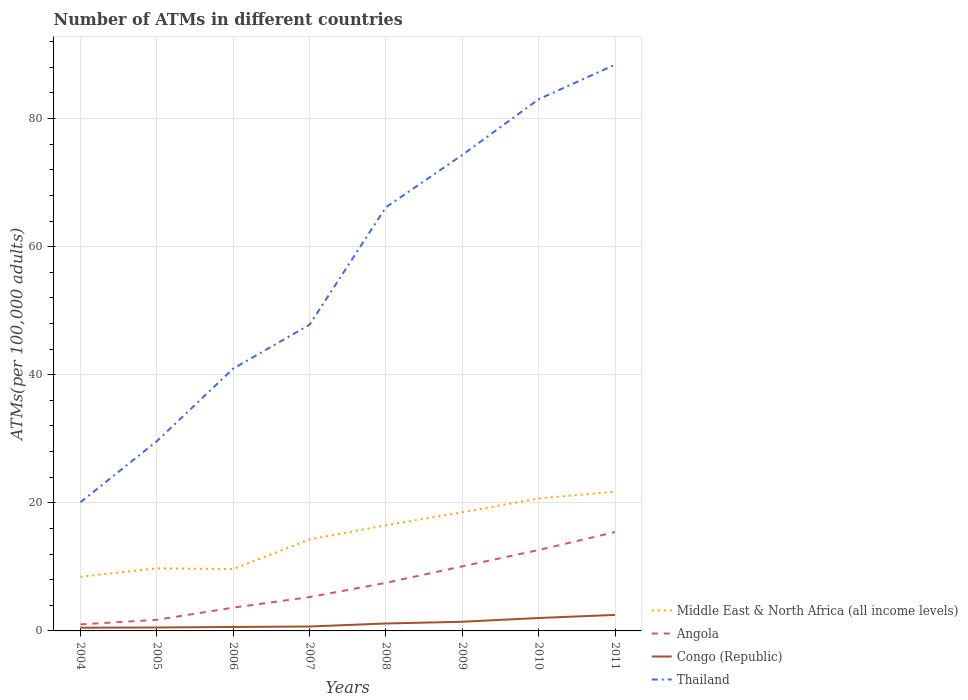Across all years, what is the maximum number of ATMs in Congo (Republic)?
Offer a very short reply. 0.5. In which year was the number of ATMs in Congo (Republic) maximum?
Give a very brief answer. 2004. What is the total number of ATMs in Middle East & North Africa (all income levels) in the graph?
Ensure brevity in your answer.  -5.83. What is the difference between the highest and the second highest number of ATMs in Congo (Republic)?
Ensure brevity in your answer.  2. Is the number of ATMs in Middle East & North Africa (all income levels) strictly greater than the number of ATMs in Angola over the years?
Your answer should be compact. No. How many years are there in the graph?
Your answer should be compact. 8. What is the difference between two consecutive major ticks on the Y-axis?
Make the answer very short. 20. How many legend labels are there?
Offer a very short reply. 4. How are the legend labels stacked?
Offer a very short reply. Vertical. What is the title of the graph?
Your answer should be very brief. Number of ATMs in different countries. Does "Djibouti" appear as one of the legend labels in the graph?
Keep it short and to the point. No. What is the label or title of the Y-axis?
Your answer should be very brief. ATMs(per 100,0 adults). What is the ATMs(per 100,000 adults) in Middle East & North Africa (all income levels) in 2004?
Your response must be concise. 8.46. What is the ATMs(per 100,000 adults) in Angola in 2004?
Make the answer very short. 1.02. What is the ATMs(per 100,000 adults) in Congo (Republic) in 2004?
Give a very brief answer. 0.5. What is the ATMs(per 100,000 adults) in Thailand in 2004?
Make the answer very short. 20.09. What is the ATMs(per 100,000 adults) in Middle East & North Africa (all income levels) in 2005?
Provide a short and direct response. 9.77. What is the ATMs(per 100,000 adults) of Angola in 2005?
Offer a very short reply. 1.74. What is the ATMs(per 100,000 adults) of Congo (Republic) in 2005?
Make the answer very short. 0.54. What is the ATMs(per 100,000 adults) in Thailand in 2005?
Your answer should be compact. 29.62. What is the ATMs(per 100,000 adults) in Middle East & North Africa (all income levels) in 2006?
Offer a very short reply. 9.67. What is the ATMs(per 100,000 adults) of Angola in 2006?
Provide a succinct answer. 3.64. What is the ATMs(per 100,000 adults) of Congo (Republic) in 2006?
Give a very brief answer. 0.62. What is the ATMs(per 100,000 adults) in Thailand in 2006?
Keep it short and to the point. 40.95. What is the ATMs(per 100,000 adults) in Middle East & North Africa (all income levels) in 2007?
Your answer should be compact. 14.28. What is the ATMs(per 100,000 adults) of Angola in 2007?
Provide a succinct answer. 5.28. What is the ATMs(per 100,000 adults) of Congo (Republic) in 2007?
Keep it short and to the point. 0.69. What is the ATMs(per 100,000 adults) in Thailand in 2007?
Give a very brief answer. 47.81. What is the ATMs(per 100,000 adults) of Middle East & North Africa (all income levels) in 2008?
Ensure brevity in your answer.  16.5. What is the ATMs(per 100,000 adults) of Angola in 2008?
Your answer should be compact. 7.51. What is the ATMs(per 100,000 adults) in Congo (Republic) in 2008?
Your response must be concise. 1.16. What is the ATMs(per 100,000 adults) of Thailand in 2008?
Keep it short and to the point. 66.15. What is the ATMs(per 100,000 adults) in Middle East & North Africa (all income levels) in 2009?
Offer a very short reply. 18.52. What is the ATMs(per 100,000 adults) in Angola in 2009?
Provide a succinct answer. 10.08. What is the ATMs(per 100,000 adults) in Congo (Republic) in 2009?
Make the answer very short. 1.43. What is the ATMs(per 100,000 adults) in Thailand in 2009?
Offer a terse response. 74.32. What is the ATMs(per 100,000 adults) of Middle East & North Africa (all income levels) in 2010?
Give a very brief answer. 20.68. What is the ATMs(per 100,000 adults) in Angola in 2010?
Offer a terse response. 12.63. What is the ATMs(per 100,000 adults) in Congo (Republic) in 2010?
Your answer should be compact. 2.02. What is the ATMs(per 100,000 adults) in Thailand in 2010?
Provide a short and direct response. 83.02. What is the ATMs(per 100,000 adults) of Middle East & North Africa (all income levels) in 2011?
Provide a succinct answer. 21.74. What is the ATMs(per 100,000 adults) of Angola in 2011?
Give a very brief answer. 15.44. What is the ATMs(per 100,000 adults) of Congo (Republic) in 2011?
Provide a short and direct response. 2.5. What is the ATMs(per 100,000 adults) in Thailand in 2011?
Your answer should be compact. 88.41. Across all years, what is the maximum ATMs(per 100,000 adults) in Middle East & North Africa (all income levels)?
Give a very brief answer. 21.74. Across all years, what is the maximum ATMs(per 100,000 adults) of Angola?
Ensure brevity in your answer.  15.44. Across all years, what is the maximum ATMs(per 100,000 adults) in Congo (Republic)?
Offer a terse response. 2.5. Across all years, what is the maximum ATMs(per 100,000 adults) of Thailand?
Ensure brevity in your answer.  88.41. Across all years, what is the minimum ATMs(per 100,000 adults) in Middle East & North Africa (all income levels)?
Provide a succinct answer. 8.46. Across all years, what is the minimum ATMs(per 100,000 adults) in Angola?
Your answer should be compact. 1.02. Across all years, what is the minimum ATMs(per 100,000 adults) of Congo (Republic)?
Provide a short and direct response. 0.5. Across all years, what is the minimum ATMs(per 100,000 adults) of Thailand?
Ensure brevity in your answer.  20.09. What is the total ATMs(per 100,000 adults) of Middle East & North Africa (all income levels) in the graph?
Give a very brief answer. 119.62. What is the total ATMs(per 100,000 adults) in Angola in the graph?
Ensure brevity in your answer.  57.34. What is the total ATMs(per 100,000 adults) of Congo (Republic) in the graph?
Provide a succinct answer. 9.46. What is the total ATMs(per 100,000 adults) in Thailand in the graph?
Offer a terse response. 450.38. What is the difference between the ATMs(per 100,000 adults) in Middle East & North Africa (all income levels) in 2004 and that in 2005?
Keep it short and to the point. -1.31. What is the difference between the ATMs(per 100,000 adults) in Angola in 2004 and that in 2005?
Your answer should be very brief. -0.72. What is the difference between the ATMs(per 100,000 adults) in Congo (Republic) in 2004 and that in 2005?
Offer a terse response. -0.04. What is the difference between the ATMs(per 100,000 adults) of Thailand in 2004 and that in 2005?
Ensure brevity in your answer.  -9.53. What is the difference between the ATMs(per 100,000 adults) in Middle East & North Africa (all income levels) in 2004 and that in 2006?
Offer a terse response. -1.21. What is the difference between the ATMs(per 100,000 adults) in Angola in 2004 and that in 2006?
Ensure brevity in your answer.  -2.62. What is the difference between the ATMs(per 100,000 adults) of Congo (Republic) in 2004 and that in 2006?
Give a very brief answer. -0.12. What is the difference between the ATMs(per 100,000 adults) in Thailand in 2004 and that in 2006?
Your answer should be compact. -20.86. What is the difference between the ATMs(per 100,000 adults) in Middle East & North Africa (all income levels) in 2004 and that in 2007?
Your answer should be compact. -5.83. What is the difference between the ATMs(per 100,000 adults) of Angola in 2004 and that in 2007?
Offer a terse response. -4.26. What is the difference between the ATMs(per 100,000 adults) of Congo (Republic) in 2004 and that in 2007?
Make the answer very short. -0.19. What is the difference between the ATMs(per 100,000 adults) in Thailand in 2004 and that in 2007?
Offer a terse response. -27.72. What is the difference between the ATMs(per 100,000 adults) in Middle East & North Africa (all income levels) in 2004 and that in 2008?
Provide a short and direct response. -8.04. What is the difference between the ATMs(per 100,000 adults) of Angola in 2004 and that in 2008?
Ensure brevity in your answer.  -6.49. What is the difference between the ATMs(per 100,000 adults) of Congo (Republic) in 2004 and that in 2008?
Your response must be concise. -0.66. What is the difference between the ATMs(per 100,000 adults) in Thailand in 2004 and that in 2008?
Offer a very short reply. -46.06. What is the difference between the ATMs(per 100,000 adults) in Middle East & North Africa (all income levels) in 2004 and that in 2009?
Your answer should be very brief. -10.07. What is the difference between the ATMs(per 100,000 adults) in Angola in 2004 and that in 2009?
Your answer should be compact. -9.06. What is the difference between the ATMs(per 100,000 adults) in Congo (Republic) in 2004 and that in 2009?
Keep it short and to the point. -0.93. What is the difference between the ATMs(per 100,000 adults) in Thailand in 2004 and that in 2009?
Your answer should be compact. -54.23. What is the difference between the ATMs(per 100,000 adults) of Middle East & North Africa (all income levels) in 2004 and that in 2010?
Give a very brief answer. -12.23. What is the difference between the ATMs(per 100,000 adults) in Angola in 2004 and that in 2010?
Offer a terse response. -11.62. What is the difference between the ATMs(per 100,000 adults) of Congo (Republic) in 2004 and that in 2010?
Keep it short and to the point. -1.52. What is the difference between the ATMs(per 100,000 adults) in Thailand in 2004 and that in 2010?
Provide a short and direct response. -62.93. What is the difference between the ATMs(per 100,000 adults) of Middle East & North Africa (all income levels) in 2004 and that in 2011?
Ensure brevity in your answer.  -13.29. What is the difference between the ATMs(per 100,000 adults) of Angola in 2004 and that in 2011?
Provide a short and direct response. -14.42. What is the difference between the ATMs(per 100,000 adults) of Congo (Republic) in 2004 and that in 2011?
Your response must be concise. -2. What is the difference between the ATMs(per 100,000 adults) of Thailand in 2004 and that in 2011?
Your response must be concise. -68.32. What is the difference between the ATMs(per 100,000 adults) of Middle East & North Africa (all income levels) in 2005 and that in 2006?
Make the answer very short. 0.1. What is the difference between the ATMs(per 100,000 adults) in Angola in 2005 and that in 2006?
Offer a terse response. -1.9. What is the difference between the ATMs(per 100,000 adults) in Congo (Republic) in 2005 and that in 2006?
Offer a very short reply. -0.08. What is the difference between the ATMs(per 100,000 adults) in Thailand in 2005 and that in 2006?
Your answer should be compact. -11.33. What is the difference between the ATMs(per 100,000 adults) in Middle East & North Africa (all income levels) in 2005 and that in 2007?
Give a very brief answer. -4.51. What is the difference between the ATMs(per 100,000 adults) of Angola in 2005 and that in 2007?
Offer a very short reply. -3.55. What is the difference between the ATMs(per 100,000 adults) in Congo (Republic) in 2005 and that in 2007?
Offer a very short reply. -0.15. What is the difference between the ATMs(per 100,000 adults) in Thailand in 2005 and that in 2007?
Offer a very short reply. -18.19. What is the difference between the ATMs(per 100,000 adults) of Middle East & North Africa (all income levels) in 2005 and that in 2008?
Your answer should be compact. -6.73. What is the difference between the ATMs(per 100,000 adults) of Angola in 2005 and that in 2008?
Keep it short and to the point. -5.77. What is the difference between the ATMs(per 100,000 adults) in Congo (Republic) in 2005 and that in 2008?
Offer a very short reply. -0.62. What is the difference between the ATMs(per 100,000 adults) in Thailand in 2005 and that in 2008?
Provide a succinct answer. -36.53. What is the difference between the ATMs(per 100,000 adults) of Middle East & North Africa (all income levels) in 2005 and that in 2009?
Provide a succinct answer. -8.76. What is the difference between the ATMs(per 100,000 adults) in Angola in 2005 and that in 2009?
Ensure brevity in your answer.  -8.35. What is the difference between the ATMs(per 100,000 adults) of Congo (Republic) in 2005 and that in 2009?
Provide a succinct answer. -0.89. What is the difference between the ATMs(per 100,000 adults) of Thailand in 2005 and that in 2009?
Provide a short and direct response. -44.69. What is the difference between the ATMs(per 100,000 adults) in Middle East & North Africa (all income levels) in 2005 and that in 2010?
Provide a succinct answer. -10.92. What is the difference between the ATMs(per 100,000 adults) in Angola in 2005 and that in 2010?
Your response must be concise. -10.9. What is the difference between the ATMs(per 100,000 adults) in Congo (Republic) in 2005 and that in 2010?
Make the answer very short. -1.48. What is the difference between the ATMs(per 100,000 adults) in Thailand in 2005 and that in 2010?
Your answer should be compact. -53.4. What is the difference between the ATMs(per 100,000 adults) of Middle East & North Africa (all income levels) in 2005 and that in 2011?
Provide a short and direct response. -11.98. What is the difference between the ATMs(per 100,000 adults) of Angola in 2005 and that in 2011?
Make the answer very short. -13.7. What is the difference between the ATMs(per 100,000 adults) of Congo (Republic) in 2005 and that in 2011?
Provide a short and direct response. -1.96. What is the difference between the ATMs(per 100,000 adults) of Thailand in 2005 and that in 2011?
Offer a terse response. -58.78. What is the difference between the ATMs(per 100,000 adults) in Middle East & North Africa (all income levels) in 2006 and that in 2007?
Keep it short and to the point. -4.61. What is the difference between the ATMs(per 100,000 adults) of Angola in 2006 and that in 2007?
Your answer should be compact. -1.65. What is the difference between the ATMs(per 100,000 adults) of Congo (Republic) in 2006 and that in 2007?
Offer a terse response. -0.07. What is the difference between the ATMs(per 100,000 adults) of Thailand in 2006 and that in 2007?
Keep it short and to the point. -6.86. What is the difference between the ATMs(per 100,000 adults) in Middle East & North Africa (all income levels) in 2006 and that in 2008?
Offer a very short reply. -6.83. What is the difference between the ATMs(per 100,000 adults) in Angola in 2006 and that in 2008?
Your response must be concise. -3.87. What is the difference between the ATMs(per 100,000 adults) of Congo (Republic) in 2006 and that in 2008?
Your response must be concise. -0.54. What is the difference between the ATMs(per 100,000 adults) in Thailand in 2006 and that in 2008?
Your answer should be compact. -25.2. What is the difference between the ATMs(per 100,000 adults) of Middle East & North Africa (all income levels) in 2006 and that in 2009?
Offer a terse response. -8.86. What is the difference between the ATMs(per 100,000 adults) of Angola in 2006 and that in 2009?
Your answer should be very brief. -6.45. What is the difference between the ATMs(per 100,000 adults) of Congo (Republic) in 2006 and that in 2009?
Provide a short and direct response. -0.81. What is the difference between the ATMs(per 100,000 adults) of Thailand in 2006 and that in 2009?
Offer a very short reply. -33.37. What is the difference between the ATMs(per 100,000 adults) in Middle East & North Africa (all income levels) in 2006 and that in 2010?
Your response must be concise. -11.02. What is the difference between the ATMs(per 100,000 adults) of Angola in 2006 and that in 2010?
Make the answer very short. -9. What is the difference between the ATMs(per 100,000 adults) in Congo (Republic) in 2006 and that in 2010?
Make the answer very short. -1.4. What is the difference between the ATMs(per 100,000 adults) in Thailand in 2006 and that in 2010?
Ensure brevity in your answer.  -42.07. What is the difference between the ATMs(per 100,000 adults) of Middle East & North Africa (all income levels) in 2006 and that in 2011?
Provide a short and direct response. -12.08. What is the difference between the ATMs(per 100,000 adults) of Angola in 2006 and that in 2011?
Make the answer very short. -11.8. What is the difference between the ATMs(per 100,000 adults) of Congo (Republic) in 2006 and that in 2011?
Offer a very short reply. -1.88. What is the difference between the ATMs(per 100,000 adults) in Thailand in 2006 and that in 2011?
Keep it short and to the point. -47.46. What is the difference between the ATMs(per 100,000 adults) in Middle East & North Africa (all income levels) in 2007 and that in 2008?
Your response must be concise. -2.22. What is the difference between the ATMs(per 100,000 adults) of Angola in 2007 and that in 2008?
Your response must be concise. -2.23. What is the difference between the ATMs(per 100,000 adults) of Congo (Republic) in 2007 and that in 2008?
Provide a succinct answer. -0.47. What is the difference between the ATMs(per 100,000 adults) of Thailand in 2007 and that in 2008?
Offer a terse response. -18.34. What is the difference between the ATMs(per 100,000 adults) in Middle East & North Africa (all income levels) in 2007 and that in 2009?
Provide a short and direct response. -4.24. What is the difference between the ATMs(per 100,000 adults) of Angola in 2007 and that in 2009?
Offer a very short reply. -4.8. What is the difference between the ATMs(per 100,000 adults) of Congo (Republic) in 2007 and that in 2009?
Make the answer very short. -0.74. What is the difference between the ATMs(per 100,000 adults) in Thailand in 2007 and that in 2009?
Make the answer very short. -26.51. What is the difference between the ATMs(per 100,000 adults) in Middle East & North Africa (all income levels) in 2007 and that in 2010?
Keep it short and to the point. -6.4. What is the difference between the ATMs(per 100,000 adults) of Angola in 2007 and that in 2010?
Provide a short and direct response. -7.35. What is the difference between the ATMs(per 100,000 adults) of Congo (Republic) in 2007 and that in 2010?
Your answer should be very brief. -1.33. What is the difference between the ATMs(per 100,000 adults) in Thailand in 2007 and that in 2010?
Ensure brevity in your answer.  -35.21. What is the difference between the ATMs(per 100,000 adults) in Middle East & North Africa (all income levels) in 2007 and that in 2011?
Your response must be concise. -7.46. What is the difference between the ATMs(per 100,000 adults) of Angola in 2007 and that in 2011?
Your response must be concise. -10.16. What is the difference between the ATMs(per 100,000 adults) of Congo (Republic) in 2007 and that in 2011?
Keep it short and to the point. -1.81. What is the difference between the ATMs(per 100,000 adults) of Thailand in 2007 and that in 2011?
Your answer should be very brief. -40.6. What is the difference between the ATMs(per 100,000 adults) in Middle East & North Africa (all income levels) in 2008 and that in 2009?
Provide a succinct answer. -2.02. What is the difference between the ATMs(per 100,000 adults) in Angola in 2008 and that in 2009?
Your response must be concise. -2.57. What is the difference between the ATMs(per 100,000 adults) in Congo (Republic) in 2008 and that in 2009?
Keep it short and to the point. -0.27. What is the difference between the ATMs(per 100,000 adults) of Thailand in 2008 and that in 2009?
Give a very brief answer. -8.17. What is the difference between the ATMs(per 100,000 adults) of Middle East & North Africa (all income levels) in 2008 and that in 2010?
Ensure brevity in your answer.  -4.18. What is the difference between the ATMs(per 100,000 adults) of Angola in 2008 and that in 2010?
Your answer should be compact. -5.12. What is the difference between the ATMs(per 100,000 adults) of Congo (Republic) in 2008 and that in 2010?
Give a very brief answer. -0.86. What is the difference between the ATMs(per 100,000 adults) of Thailand in 2008 and that in 2010?
Offer a very short reply. -16.87. What is the difference between the ATMs(per 100,000 adults) of Middle East & North Africa (all income levels) in 2008 and that in 2011?
Provide a succinct answer. -5.24. What is the difference between the ATMs(per 100,000 adults) of Angola in 2008 and that in 2011?
Offer a terse response. -7.93. What is the difference between the ATMs(per 100,000 adults) in Congo (Republic) in 2008 and that in 2011?
Offer a very short reply. -1.34. What is the difference between the ATMs(per 100,000 adults) in Thailand in 2008 and that in 2011?
Ensure brevity in your answer.  -22.26. What is the difference between the ATMs(per 100,000 adults) of Middle East & North Africa (all income levels) in 2009 and that in 2010?
Your answer should be compact. -2.16. What is the difference between the ATMs(per 100,000 adults) of Angola in 2009 and that in 2010?
Provide a short and direct response. -2.55. What is the difference between the ATMs(per 100,000 adults) of Congo (Republic) in 2009 and that in 2010?
Give a very brief answer. -0.59. What is the difference between the ATMs(per 100,000 adults) of Thailand in 2009 and that in 2010?
Give a very brief answer. -8.7. What is the difference between the ATMs(per 100,000 adults) in Middle East & North Africa (all income levels) in 2009 and that in 2011?
Provide a short and direct response. -3.22. What is the difference between the ATMs(per 100,000 adults) in Angola in 2009 and that in 2011?
Provide a succinct answer. -5.36. What is the difference between the ATMs(per 100,000 adults) of Congo (Republic) in 2009 and that in 2011?
Provide a succinct answer. -1.07. What is the difference between the ATMs(per 100,000 adults) in Thailand in 2009 and that in 2011?
Provide a short and direct response. -14.09. What is the difference between the ATMs(per 100,000 adults) of Middle East & North Africa (all income levels) in 2010 and that in 2011?
Your answer should be compact. -1.06. What is the difference between the ATMs(per 100,000 adults) in Angola in 2010 and that in 2011?
Ensure brevity in your answer.  -2.81. What is the difference between the ATMs(per 100,000 adults) in Congo (Republic) in 2010 and that in 2011?
Ensure brevity in your answer.  -0.48. What is the difference between the ATMs(per 100,000 adults) in Thailand in 2010 and that in 2011?
Give a very brief answer. -5.39. What is the difference between the ATMs(per 100,000 adults) in Middle East & North Africa (all income levels) in 2004 and the ATMs(per 100,000 adults) in Angola in 2005?
Offer a very short reply. 6.72. What is the difference between the ATMs(per 100,000 adults) in Middle East & North Africa (all income levels) in 2004 and the ATMs(per 100,000 adults) in Congo (Republic) in 2005?
Offer a very short reply. 7.92. What is the difference between the ATMs(per 100,000 adults) of Middle East & North Africa (all income levels) in 2004 and the ATMs(per 100,000 adults) of Thailand in 2005?
Your answer should be very brief. -21.17. What is the difference between the ATMs(per 100,000 adults) in Angola in 2004 and the ATMs(per 100,000 adults) in Congo (Republic) in 2005?
Ensure brevity in your answer.  0.48. What is the difference between the ATMs(per 100,000 adults) of Angola in 2004 and the ATMs(per 100,000 adults) of Thailand in 2005?
Your answer should be compact. -28.61. What is the difference between the ATMs(per 100,000 adults) of Congo (Republic) in 2004 and the ATMs(per 100,000 adults) of Thailand in 2005?
Your answer should be very brief. -29.12. What is the difference between the ATMs(per 100,000 adults) of Middle East & North Africa (all income levels) in 2004 and the ATMs(per 100,000 adults) of Angola in 2006?
Your response must be concise. 4.82. What is the difference between the ATMs(per 100,000 adults) in Middle East & North Africa (all income levels) in 2004 and the ATMs(per 100,000 adults) in Congo (Republic) in 2006?
Ensure brevity in your answer.  7.84. What is the difference between the ATMs(per 100,000 adults) of Middle East & North Africa (all income levels) in 2004 and the ATMs(per 100,000 adults) of Thailand in 2006?
Your answer should be very brief. -32.5. What is the difference between the ATMs(per 100,000 adults) of Angola in 2004 and the ATMs(per 100,000 adults) of Congo (Republic) in 2006?
Provide a short and direct response. 0.4. What is the difference between the ATMs(per 100,000 adults) in Angola in 2004 and the ATMs(per 100,000 adults) in Thailand in 2006?
Your response must be concise. -39.93. What is the difference between the ATMs(per 100,000 adults) of Congo (Republic) in 2004 and the ATMs(per 100,000 adults) of Thailand in 2006?
Ensure brevity in your answer.  -40.45. What is the difference between the ATMs(per 100,000 adults) of Middle East & North Africa (all income levels) in 2004 and the ATMs(per 100,000 adults) of Angola in 2007?
Offer a very short reply. 3.17. What is the difference between the ATMs(per 100,000 adults) in Middle East & North Africa (all income levels) in 2004 and the ATMs(per 100,000 adults) in Congo (Republic) in 2007?
Offer a terse response. 7.76. What is the difference between the ATMs(per 100,000 adults) of Middle East & North Africa (all income levels) in 2004 and the ATMs(per 100,000 adults) of Thailand in 2007?
Provide a succinct answer. -39.36. What is the difference between the ATMs(per 100,000 adults) in Angola in 2004 and the ATMs(per 100,000 adults) in Congo (Republic) in 2007?
Provide a short and direct response. 0.33. What is the difference between the ATMs(per 100,000 adults) of Angola in 2004 and the ATMs(per 100,000 adults) of Thailand in 2007?
Ensure brevity in your answer.  -46.79. What is the difference between the ATMs(per 100,000 adults) in Congo (Republic) in 2004 and the ATMs(per 100,000 adults) in Thailand in 2007?
Your answer should be compact. -47.31. What is the difference between the ATMs(per 100,000 adults) of Middle East & North Africa (all income levels) in 2004 and the ATMs(per 100,000 adults) of Angola in 2008?
Offer a terse response. 0.95. What is the difference between the ATMs(per 100,000 adults) in Middle East & North Africa (all income levels) in 2004 and the ATMs(per 100,000 adults) in Congo (Republic) in 2008?
Offer a terse response. 7.29. What is the difference between the ATMs(per 100,000 adults) of Middle East & North Africa (all income levels) in 2004 and the ATMs(per 100,000 adults) of Thailand in 2008?
Your answer should be very brief. -57.7. What is the difference between the ATMs(per 100,000 adults) of Angola in 2004 and the ATMs(per 100,000 adults) of Congo (Republic) in 2008?
Provide a succinct answer. -0.14. What is the difference between the ATMs(per 100,000 adults) in Angola in 2004 and the ATMs(per 100,000 adults) in Thailand in 2008?
Offer a very short reply. -65.13. What is the difference between the ATMs(per 100,000 adults) of Congo (Republic) in 2004 and the ATMs(per 100,000 adults) of Thailand in 2008?
Ensure brevity in your answer.  -65.65. What is the difference between the ATMs(per 100,000 adults) in Middle East & North Africa (all income levels) in 2004 and the ATMs(per 100,000 adults) in Angola in 2009?
Keep it short and to the point. -1.63. What is the difference between the ATMs(per 100,000 adults) in Middle East & North Africa (all income levels) in 2004 and the ATMs(per 100,000 adults) in Congo (Republic) in 2009?
Your response must be concise. 7.03. What is the difference between the ATMs(per 100,000 adults) of Middle East & North Africa (all income levels) in 2004 and the ATMs(per 100,000 adults) of Thailand in 2009?
Your answer should be very brief. -65.86. What is the difference between the ATMs(per 100,000 adults) of Angola in 2004 and the ATMs(per 100,000 adults) of Congo (Republic) in 2009?
Your response must be concise. -0.41. What is the difference between the ATMs(per 100,000 adults) of Angola in 2004 and the ATMs(per 100,000 adults) of Thailand in 2009?
Your answer should be compact. -73.3. What is the difference between the ATMs(per 100,000 adults) in Congo (Republic) in 2004 and the ATMs(per 100,000 adults) in Thailand in 2009?
Provide a short and direct response. -73.82. What is the difference between the ATMs(per 100,000 adults) in Middle East & North Africa (all income levels) in 2004 and the ATMs(per 100,000 adults) in Angola in 2010?
Offer a very short reply. -4.18. What is the difference between the ATMs(per 100,000 adults) of Middle East & North Africa (all income levels) in 2004 and the ATMs(per 100,000 adults) of Congo (Republic) in 2010?
Your response must be concise. 6.43. What is the difference between the ATMs(per 100,000 adults) of Middle East & North Africa (all income levels) in 2004 and the ATMs(per 100,000 adults) of Thailand in 2010?
Make the answer very short. -74.57. What is the difference between the ATMs(per 100,000 adults) of Angola in 2004 and the ATMs(per 100,000 adults) of Congo (Republic) in 2010?
Offer a terse response. -1. What is the difference between the ATMs(per 100,000 adults) of Angola in 2004 and the ATMs(per 100,000 adults) of Thailand in 2010?
Provide a succinct answer. -82. What is the difference between the ATMs(per 100,000 adults) of Congo (Republic) in 2004 and the ATMs(per 100,000 adults) of Thailand in 2010?
Your answer should be very brief. -82.52. What is the difference between the ATMs(per 100,000 adults) of Middle East & North Africa (all income levels) in 2004 and the ATMs(per 100,000 adults) of Angola in 2011?
Keep it short and to the point. -6.98. What is the difference between the ATMs(per 100,000 adults) of Middle East & North Africa (all income levels) in 2004 and the ATMs(per 100,000 adults) of Congo (Republic) in 2011?
Keep it short and to the point. 5.95. What is the difference between the ATMs(per 100,000 adults) of Middle East & North Africa (all income levels) in 2004 and the ATMs(per 100,000 adults) of Thailand in 2011?
Ensure brevity in your answer.  -79.95. What is the difference between the ATMs(per 100,000 adults) in Angola in 2004 and the ATMs(per 100,000 adults) in Congo (Republic) in 2011?
Your response must be concise. -1.48. What is the difference between the ATMs(per 100,000 adults) in Angola in 2004 and the ATMs(per 100,000 adults) in Thailand in 2011?
Offer a terse response. -87.39. What is the difference between the ATMs(per 100,000 adults) of Congo (Republic) in 2004 and the ATMs(per 100,000 adults) of Thailand in 2011?
Your answer should be compact. -87.91. What is the difference between the ATMs(per 100,000 adults) in Middle East & North Africa (all income levels) in 2005 and the ATMs(per 100,000 adults) in Angola in 2006?
Provide a short and direct response. 6.13. What is the difference between the ATMs(per 100,000 adults) of Middle East & North Africa (all income levels) in 2005 and the ATMs(per 100,000 adults) of Congo (Republic) in 2006?
Provide a short and direct response. 9.15. What is the difference between the ATMs(per 100,000 adults) in Middle East & North Africa (all income levels) in 2005 and the ATMs(per 100,000 adults) in Thailand in 2006?
Give a very brief answer. -31.18. What is the difference between the ATMs(per 100,000 adults) in Angola in 2005 and the ATMs(per 100,000 adults) in Congo (Republic) in 2006?
Keep it short and to the point. 1.12. What is the difference between the ATMs(per 100,000 adults) of Angola in 2005 and the ATMs(per 100,000 adults) of Thailand in 2006?
Give a very brief answer. -39.22. What is the difference between the ATMs(per 100,000 adults) of Congo (Republic) in 2005 and the ATMs(per 100,000 adults) of Thailand in 2006?
Offer a very short reply. -40.41. What is the difference between the ATMs(per 100,000 adults) in Middle East & North Africa (all income levels) in 2005 and the ATMs(per 100,000 adults) in Angola in 2007?
Give a very brief answer. 4.48. What is the difference between the ATMs(per 100,000 adults) of Middle East & North Africa (all income levels) in 2005 and the ATMs(per 100,000 adults) of Congo (Republic) in 2007?
Offer a very short reply. 9.08. What is the difference between the ATMs(per 100,000 adults) of Middle East & North Africa (all income levels) in 2005 and the ATMs(per 100,000 adults) of Thailand in 2007?
Ensure brevity in your answer.  -38.04. What is the difference between the ATMs(per 100,000 adults) of Angola in 2005 and the ATMs(per 100,000 adults) of Congo (Republic) in 2007?
Your answer should be very brief. 1.05. What is the difference between the ATMs(per 100,000 adults) of Angola in 2005 and the ATMs(per 100,000 adults) of Thailand in 2007?
Give a very brief answer. -46.07. What is the difference between the ATMs(per 100,000 adults) of Congo (Republic) in 2005 and the ATMs(per 100,000 adults) of Thailand in 2007?
Provide a succinct answer. -47.27. What is the difference between the ATMs(per 100,000 adults) in Middle East & North Africa (all income levels) in 2005 and the ATMs(per 100,000 adults) in Angola in 2008?
Ensure brevity in your answer.  2.26. What is the difference between the ATMs(per 100,000 adults) of Middle East & North Africa (all income levels) in 2005 and the ATMs(per 100,000 adults) of Congo (Republic) in 2008?
Keep it short and to the point. 8.61. What is the difference between the ATMs(per 100,000 adults) of Middle East & North Africa (all income levels) in 2005 and the ATMs(per 100,000 adults) of Thailand in 2008?
Make the answer very short. -56.39. What is the difference between the ATMs(per 100,000 adults) of Angola in 2005 and the ATMs(per 100,000 adults) of Congo (Republic) in 2008?
Your answer should be compact. 0.58. What is the difference between the ATMs(per 100,000 adults) in Angola in 2005 and the ATMs(per 100,000 adults) in Thailand in 2008?
Provide a succinct answer. -64.42. What is the difference between the ATMs(per 100,000 adults) of Congo (Republic) in 2005 and the ATMs(per 100,000 adults) of Thailand in 2008?
Your answer should be compact. -65.62. What is the difference between the ATMs(per 100,000 adults) of Middle East & North Africa (all income levels) in 2005 and the ATMs(per 100,000 adults) of Angola in 2009?
Your response must be concise. -0.32. What is the difference between the ATMs(per 100,000 adults) in Middle East & North Africa (all income levels) in 2005 and the ATMs(per 100,000 adults) in Congo (Republic) in 2009?
Make the answer very short. 8.34. What is the difference between the ATMs(per 100,000 adults) in Middle East & North Africa (all income levels) in 2005 and the ATMs(per 100,000 adults) in Thailand in 2009?
Provide a succinct answer. -64.55. What is the difference between the ATMs(per 100,000 adults) of Angola in 2005 and the ATMs(per 100,000 adults) of Congo (Republic) in 2009?
Your response must be concise. 0.31. What is the difference between the ATMs(per 100,000 adults) of Angola in 2005 and the ATMs(per 100,000 adults) of Thailand in 2009?
Keep it short and to the point. -72.58. What is the difference between the ATMs(per 100,000 adults) in Congo (Republic) in 2005 and the ATMs(per 100,000 adults) in Thailand in 2009?
Your response must be concise. -73.78. What is the difference between the ATMs(per 100,000 adults) of Middle East & North Africa (all income levels) in 2005 and the ATMs(per 100,000 adults) of Angola in 2010?
Your answer should be compact. -2.87. What is the difference between the ATMs(per 100,000 adults) of Middle East & North Africa (all income levels) in 2005 and the ATMs(per 100,000 adults) of Congo (Republic) in 2010?
Make the answer very short. 7.75. What is the difference between the ATMs(per 100,000 adults) of Middle East & North Africa (all income levels) in 2005 and the ATMs(per 100,000 adults) of Thailand in 2010?
Make the answer very short. -73.25. What is the difference between the ATMs(per 100,000 adults) in Angola in 2005 and the ATMs(per 100,000 adults) in Congo (Republic) in 2010?
Offer a terse response. -0.28. What is the difference between the ATMs(per 100,000 adults) in Angola in 2005 and the ATMs(per 100,000 adults) in Thailand in 2010?
Keep it short and to the point. -81.28. What is the difference between the ATMs(per 100,000 adults) of Congo (Republic) in 2005 and the ATMs(per 100,000 adults) of Thailand in 2010?
Keep it short and to the point. -82.48. What is the difference between the ATMs(per 100,000 adults) in Middle East & North Africa (all income levels) in 2005 and the ATMs(per 100,000 adults) in Angola in 2011?
Make the answer very short. -5.67. What is the difference between the ATMs(per 100,000 adults) in Middle East & North Africa (all income levels) in 2005 and the ATMs(per 100,000 adults) in Congo (Republic) in 2011?
Make the answer very short. 7.27. What is the difference between the ATMs(per 100,000 adults) in Middle East & North Africa (all income levels) in 2005 and the ATMs(per 100,000 adults) in Thailand in 2011?
Provide a succinct answer. -78.64. What is the difference between the ATMs(per 100,000 adults) in Angola in 2005 and the ATMs(per 100,000 adults) in Congo (Republic) in 2011?
Offer a terse response. -0.77. What is the difference between the ATMs(per 100,000 adults) of Angola in 2005 and the ATMs(per 100,000 adults) of Thailand in 2011?
Offer a very short reply. -86.67. What is the difference between the ATMs(per 100,000 adults) in Congo (Republic) in 2005 and the ATMs(per 100,000 adults) in Thailand in 2011?
Give a very brief answer. -87.87. What is the difference between the ATMs(per 100,000 adults) in Middle East & North Africa (all income levels) in 2006 and the ATMs(per 100,000 adults) in Angola in 2007?
Your response must be concise. 4.38. What is the difference between the ATMs(per 100,000 adults) of Middle East & North Africa (all income levels) in 2006 and the ATMs(per 100,000 adults) of Congo (Republic) in 2007?
Keep it short and to the point. 8.98. What is the difference between the ATMs(per 100,000 adults) in Middle East & North Africa (all income levels) in 2006 and the ATMs(per 100,000 adults) in Thailand in 2007?
Your response must be concise. -38.14. What is the difference between the ATMs(per 100,000 adults) in Angola in 2006 and the ATMs(per 100,000 adults) in Congo (Republic) in 2007?
Keep it short and to the point. 2.95. What is the difference between the ATMs(per 100,000 adults) of Angola in 2006 and the ATMs(per 100,000 adults) of Thailand in 2007?
Offer a terse response. -44.17. What is the difference between the ATMs(per 100,000 adults) of Congo (Republic) in 2006 and the ATMs(per 100,000 adults) of Thailand in 2007?
Your response must be concise. -47.19. What is the difference between the ATMs(per 100,000 adults) in Middle East & North Africa (all income levels) in 2006 and the ATMs(per 100,000 adults) in Angola in 2008?
Your answer should be very brief. 2.16. What is the difference between the ATMs(per 100,000 adults) in Middle East & North Africa (all income levels) in 2006 and the ATMs(per 100,000 adults) in Congo (Republic) in 2008?
Make the answer very short. 8.51. What is the difference between the ATMs(per 100,000 adults) of Middle East & North Africa (all income levels) in 2006 and the ATMs(per 100,000 adults) of Thailand in 2008?
Offer a terse response. -56.49. What is the difference between the ATMs(per 100,000 adults) in Angola in 2006 and the ATMs(per 100,000 adults) in Congo (Republic) in 2008?
Ensure brevity in your answer.  2.48. What is the difference between the ATMs(per 100,000 adults) in Angola in 2006 and the ATMs(per 100,000 adults) in Thailand in 2008?
Your answer should be very brief. -62.52. What is the difference between the ATMs(per 100,000 adults) of Congo (Republic) in 2006 and the ATMs(per 100,000 adults) of Thailand in 2008?
Ensure brevity in your answer.  -65.54. What is the difference between the ATMs(per 100,000 adults) in Middle East & North Africa (all income levels) in 2006 and the ATMs(per 100,000 adults) in Angola in 2009?
Make the answer very short. -0.42. What is the difference between the ATMs(per 100,000 adults) of Middle East & North Africa (all income levels) in 2006 and the ATMs(per 100,000 adults) of Congo (Republic) in 2009?
Keep it short and to the point. 8.24. What is the difference between the ATMs(per 100,000 adults) of Middle East & North Africa (all income levels) in 2006 and the ATMs(per 100,000 adults) of Thailand in 2009?
Keep it short and to the point. -64.65. What is the difference between the ATMs(per 100,000 adults) in Angola in 2006 and the ATMs(per 100,000 adults) in Congo (Republic) in 2009?
Make the answer very short. 2.21. What is the difference between the ATMs(per 100,000 adults) in Angola in 2006 and the ATMs(per 100,000 adults) in Thailand in 2009?
Give a very brief answer. -70.68. What is the difference between the ATMs(per 100,000 adults) in Congo (Republic) in 2006 and the ATMs(per 100,000 adults) in Thailand in 2009?
Give a very brief answer. -73.7. What is the difference between the ATMs(per 100,000 adults) in Middle East & North Africa (all income levels) in 2006 and the ATMs(per 100,000 adults) in Angola in 2010?
Provide a succinct answer. -2.97. What is the difference between the ATMs(per 100,000 adults) in Middle East & North Africa (all income levels) in 2006 and the ATMs(per 100,000 adults) in Congo (Republic) in 2010?
Provide a succinct answer. 7.65. What is the difference between the ATMs(per 100,000 adults) in Middle East & North Africa (all income levels) in 2006 and the ATMs(per 100,000 adults) in Thailand in 2010?
Your answer should be compact. -73.35. What is the difference between the ATMs(per 100,000 adults) in Angola in 2006 and the ATMs(per 100,000 adults) in Congo (Republic) in 2010?
Make the answer very short. 1.62. What is the difference between the ATMs(per 100,000 adults) of Angola in 2006 and the ATMs(per 100,000 adults) of Thailand in 2010?
Your answer should be compact. -79.38. What is the difference between the ATMs(per 100,000 adults) of Congo (Republic) in 2006 and the ATMs(per 100,000 adults) of Thailand in 2010?
Give a very brief answer. -82.4. What is the difference between the ATMs(per 100,000 adults) of Middle East & North Africa (all income levels) in 2006 and the ATMs(per 100,000 adults) of Angola in 2011?
Ensure brevity in your answer.  -5.77. What is the difference between the ATMs(per 100,000 adults) in Middle East & North Africa (all income levels) in 2006 and the ATMs(per 100,000 adults) in Congo (Republic) in 2011?
Provide a succinct answer. 7.17. What is the difference between the ATMs(per 100,000 adults) in Middle East & North Africa (all income levels) in 2006 and the ATMs(per 100,000 adults) in Thailand in 2011?
Offer a terse response. -78.74. What is the difference between the ATMs(per 100,000 adults) of Angola in 2006 and the ATMs(per 100,000 adults) of Congo (Republic) in 2011?
Your response must be concise. 1.14. What is the difference between the ATMs(per 100,000 adults) of Angola in 2006 and the ATMs(per 100,000 adults) of Thailand in 2011?
Your response must be concise. -84.77. What is the difference between the ATMs(per 100,000 adults) of Congo (Republic) in 2006 and the ATMs(per 100,000 adults) of Thailand in 2011?
Provide a succinct answer. -87.79. What is the difference between the ATMs(per 100,000 adults) in Middle East & North Africa (all income levels) in 2007 and the ATMs(per 100,000 adults) in Angola in 2008?
Your answer should be compact. 6.77. What is the difference between the ATMs(per 100,000 adults) in Middle East & North Africa (all income levels) in 2007 and the ATMs(per 100,000 adults) in Congo (Republic) in 2008?
Provide a short and direct response. 13.12. What is the difference between the ATMs(per 100,000 adults) in Middle East & North Africa (all income levels) in 2007 and the ATMs(per 100,000 adults) in Thailand in 2008?
Offer a terse response. -51.87. What is the difference between the ATMs(per 100,000 adults) in Angola in 2007 and the ATMs(per 100,000 adults) in Congo (Republic) in 2008?
Provide a short and direct response. 4.12. What is the difference between the ATMs(per 100,000 adults) in Angola in 2007 and the ATMs(per 100,000 adults) in Thailand in 2008?
Your answer should be compact. -60.87. What is the difference between the ATMs(per 100,000 adults) in Congo (Republic) in 2007 and the ATMs(per 100,000 adults) in Thailand in 2008?
Your answer should be very brief. -65.46. What is the difference between the ATMs(per 100,000 adults) of Middle East & North Africa (all income levels) in 2007 and the ATMs(per 100,000 adults) of Angola in 2009?
Give a very brief answer. 4.2. What is the difference between the ATMs(per 100,000 adults) of Middle East & North Africa (all income levels) in 2007 and the ATMs(per 100,000 adults) of Congo (Republic) in 2009?
Make the answer very short. 12.85. What is the difference between the ATMs(per 100,000 adults) in Middle East & North Africa (all income levels) in 2007 and the ATMs(per 100,000 adults) in Thailand in 2009?
Provide a succinct answer. -60.04. What is the difference between the ATMs(per 100,000 adults) in Angola in 2007 and the ATMs(per 100,000 adults) in Congo (Republic) in 2009?
Make the answer very short. 3.85. What is the difference between the ATMs(per 100,000 adults) of Angola in 2007 and the ATMs(per 100,000 adults) of Thailand in 2009?
Provide a succinct answer. -69.03. What is the difference between the ATMs(per 100,000 adults) of Congo (Republic) in 2007 and the ATMs(per 100,000 adults) of Thailand in 2009?
Offer a very short reply. -73.63. What is the difference between the ATMs(per 100,000 adults) of Middle East & North Africa (all income levels) in 2007 and the ATMs(per 100,000 adults) of Angola in 2010?
Your answer should be compact. 1.65. What is the difference between the ATMs(per 100,000 adults) in Middle East & North Africa (all income levels) in 2007 and the ATMs(per 100,000 adults) in Congo (Republic) in 2010?
Make the answer very short. 12.26. What is the difference between the ATMs(per 100,000 adults) of Middle East & North Africa (all income levels) in 2007 and the ATMs(per 100,000 adults) of Thailand in 2010?
Provide a short and direct response. -68.74. What is the difference between the ATMs(per 100,000 adults) in Angola in 2007 and the ATMs(per 100,000 adults) in Congo (Republic) in 2010?
Ensure brevity in your answer.  3.26. What is the difference between the ATMs(per 100,000 adults) of Angola in 2007 and the ATMs(per 100,000 adults) of Thailand in 2010?
Your response must be concise. -77.74. What is the difference between the ATMs(per 100,000 adults) in Congo (Republic) in 2007 and the ATMs(per 100,000 adults) in Thailand in 2010?
Provide a succinct answer. -82.33. What is the difference between the ATMs(per 100,000 adults) of Middle East & North Africa (all income levels) in 2007 and the ATMs(per 100,000 adults) of Angola in 2011?
Your answer should be compact. -1.16. What is the difference between the ATMs(per 100,000 adults) of Middle East & North Africa (all income levels) in 2007 and the ATMs(per 100,000 adults) of Congo (Republic) in 2011?
Your answer should be very brief. 11.78. What is the difference between the ATMs(per 100,000 adults) of Middle East & North Africa (all income levels) in 2007 and the ATMs(per 100,000 adults) of Thailand in 2011?
Ensure brevity in your answer.  -74.13. What is the difference between the ATMs(per 100,000 adults) in Angola in 2007 and the ATMs(per 100,000 adults) in Congo (Republic) in 2011?
Provide a short and direct response. 2.78. What is the difference between the ATMs(per 100,000 adults) of Angola in 2007 and the ATMs(per 100,000 adults) of Thailand in 2011?
Give a very brief answer. -83.12. What is the difference between the ATMs(per 100,000 adults) of Congo (Republic) in 2007 and the ATMs(per 100,000 adults) of Thailand in 2011?
Offer a terse response. -87.72. What is the difference between the ATMs(per 100,000 adults) in Middle East & North Africa (all income levels) in 2008 and the ATMs(per 100,000 adults) in Angola in 2009?
Your answer should be very brief. 6.42. What is the difference between the ATMs(per 100,000 adults) of Middle East & North Africa (all income levels) in 2008 and the ATMs(per 100,000 adults) of Congo (Republic) in 2009?
Give a very brief answer. 15.07. What is the difference between the ATMs(per 100,000 adults) of Middle East & North Africa (all income levels) in 2008 and the ATMs(per 100,000 adults) of Thailand in 2009?
Keep it short and to the point. -57.82. What is the difference between the ATMs(per 100,000 adults) of Angola in 2008 and the ATMs(per 100,000 adults) of Congo (Republic) in 2009?
Offer a very short reply. 6.08. What is the difference between the ATMs(per 100,000 adults) in Angola in 2008 and the ATMs(per 100,000 adults) in Thailand in 2009?
Your answer should be very brief. -66.81. What is the difference between the ATMs(per 100,000 adults) of Congo (Republic) in 2008 and the ATMs(per 100,000 adults) of Thailand in 2009?
Ensure brevity in your answer.  -73.16. What is the difference between the ATMs(per 100,000 adults) of Middle East & North Africa (all income levels) in 2008 and the ATMs(per 100,000 adults) of Angola in 2010?
Your answer should be compact. 3.87. What is the difference between the ATMs(per 100,000 adults) of Middle East & North Africa (all income levels) in 2008 and the ATMs(per 100,000 adults) of Congo (Republic) in 2010?
Your answer should be very brief. 14.48. What is the difference between the ATMs(per 100,000 adults) in Middle East & North Africa (all income levels) in 2008 and the ATMs(per 100,000 adults) in Thailand in 2010?
Provide a short and direct response. -66.52. What is the difference between the ATMs(per 100,000 adults) of Angola in 2008 and the ATMs(per 100,000 adults) of Congo (Republic) in 2010?
Ensure brevity in your answer.  5.49. What is the difference between the ATMs(per 100,000 adults) in Angola in 2008 and the ATMs(per 100,000 adults) in Thailand in 2010?
Offer a terse response. -75.51. What is the difference between the ATMs(per 100,000 adults) of Congo (Republic) in 2008 and the ATMs(per 100,000 adults) of Thailand in 2010?
Provide a short and direct response. -81.86. What is the difference between the ATMs(per 100,000 adults) in Middle East & North Africa (all income levels) in 2008 and the ATMs(per 100,000 adults) in Angola in 2011?
Offer a very short reply. 1.06. What is the difference between the ATMs(per 100,000 adults) in Middle East & North Africa (all income levels) in 2008 and the ATMs(per 100,000 adults) in Congo (Republic) in 2011?
Offer a very short reply. 14. What is the difference between the ATMs(per 100,000 adults) of Middle East & North Africa (all income levels) in 2008 and the ATMs(per 100,000 adults) of Thailand in 2011?
Offer a terse response. -71.91. What is the difference between the ATMs(per 100,000 adults) of Angola in 2008 and the ATMs(per 100,000 adults) of Congo (Republic) in 2011?
Offer a very short reply. 5.01. What is the difference between the ATMs(per 100,000 adults) of Angola in 2008 and the ATMs(per 100,000 adults) of Thailand in 2011?
Offer a very short reply. -80.9. What is the difference between the ATMs(per 100,000 adults) in Congo (Republic) in 2008 and the ATMs(per 100,000 adults) in Thailand in 2011?
Keep it short and to the point. -87.25. What is the difference between the ATMs(per 100,000 adults) of Middle East & North Africa (all income levels) in 2009 and the ATMs(per 100,000 adults) of Angola in 2010?
Your response must be concise. 5.89. What is the difference between the ATMs(per 100,000 adults) in Middle East & North Africa (all income levels) in 2009 and the ATMs(per 100,000 adults) in Congo (Republic) in 2010?
Give a very brief answer. 16.5. What is the difference between the ATMs(per 100,000 adults) of Middle East & North Africa (all income levels) in 2009 and the ATMs(per 100,000 adults) of Thailand in 2010?
Offer a very short reply. -64.5. What is the difference between the ATMs(per 100,000 adults) of Angola in 2009 and the ATMs(per 100,000 adults) of Congo (Republic) in 2010?
Make the answer very short. 8.06. What is the difference between the ATMs(per 100,000 adults) in Angola in 2009 and the ATMs(per 100,000 adults) in Thailand in 2010?
Give a very brief answer. -72.94. What is the difference between the ATMs(per 100,000 adults) in Congo (Republic) in 2009 and the ATMs(per 100,000 adults) in Thailand in 2010?
Give a very brief answer. -81.59. What is the difference between the ATMs(per 100,000 adults) in Middle East & North Africa (all income levels) in 2009 and the ATMs(per 100,000 adults) in Angola in 2011?
Offer a very short reply. 3.08. What is the difference between the ATMs(per 100,000 adults) of Middle East & North Africa (all income levels) in 2009 and the ATMs(per 100,000 adults) of Congo (Republic) in 2011?
Make the answer very short. 16.02. What is the difference between the ATMs(per 100,000 adults) in Middle East & North Africa (all income levels) in 2009 and the ATMs(per 100,000 adults) in Thailand in 2011?
Your answer should be compact. -69.89. What is the difference between the ATMs(per 100,000 adults) in Angola in 2009 and the ATMs(per 100,000 adults) in Congo (Republic) in 2011?
Offer a terse response. 7.58. What is the difference between the ATMs(per 100,000 adults) in Angola in 2009 and the ATMs(per 100,000 adults) in Thailand in 2011?
Provide a short and direct response. -78.33. What is the difference between the ATMs(per 100,000 adults) of Congo (Republic) in 2009 and the ATMs(per 100,000 adults) of Thailand in 2011?
Your answer should be compact. -86.98. What is the difference between the ATMs(per 100,000 adults) of Middle East & North Africa (all income levels) in 2010 and the ATMs(per 100,000 adults) of Angola in 2011?
Your answer should be compact. 5.25. What is the difference between the ATMs(per 100,000 adults) of Middle East & North Africa (all income levels) in 2010 and the ATMs(per 100,000 adults) of Congo (Republic) in 2011?
Your answer should be very brief. 18.18. What is the difference between the ATMs(per 100,000 adults) in Middle East & North Africa (all income levels) in 2010 and the ATMs(per 100,000 adults) in Thailand in 2011?
Make the answer very short. -67.72. What is the difference between the ATMs(per 100,000 adults) of Angola in 2010 and the ATMs(per 100,000 adults) of Congo (Republic) in 2011?
Your answer should be very brief. 10.13. What is the difference between the ATMs(per 100,000 adults) in Angola in 2010 and the ATMs(per 100,000 adults) in Thailand in 2011?
Provide a short and direct response. -75.78. What is the difference between the ATMs(per 100,000 adults) in Congo (Republic) in 2010 and the ATMs(per 100,000 adults) in Thailand in 2011?
Offer a terse response. -86.39. What is the average ATMs(per 100,000 adults) of Middle East & North Africa (all income levels) per year?
Your answer should be very brief. 14.95. What is the average ATMs(per 100,000 adults) of Angola per year?
Ensure brevity in your answer.  7.17. What is the average ATMs(per 100,000 adults) in Congo (Republic) per year?
Make the answer very short. 1.18. What is the average ATMs(per 100,000 adults) of Thailand per year?
Give a very brief answer. 56.3. In the year 2004, what is the difference between the ATMs(per 100,000 adults) of Middle East & North Africa (all income levels) and ATMs(per 100,000 adults) of Angola?
Keep it short and to the point. 7.44. In the year 2004, what is the difference between the ATMs(per 100,000 adults) in Middle East & North Africa (all income levels) and ATMs(per 100,000 adults) in Congo (Republic)?
Keep it short and to the point. 7.95. In the year 2004, what is the difference between the ATMs(per 100,000 adults) of Middle East & North Africa (all income levels) and ATMs(per 100,000 adults) of Thailand?
Your response must be concise. -11.63. In the year 2004, what is the difference between the ATMs(per 100,000 adults) of Angola and ATMs(per 100,000 adults) of Congo (Republic)?
Your answer should be very brief. 0.52. In the year 2004, what is the difference between the ATMs(per 100,000 adults) of Angola and ATMs(per 100,000 adults) of Thailand?
Offer a very short reply. -19.07. In the year 2004, what is the difference between the ATMs(per 100,000 adults) of Congo (Republic) and ATMs(per 100,000 adults) of Thailand?
Your answer should be compact. -19.59. In the year 2005, what is the difference between the ATMs(per 100,000 adults) of Middle East & North Africa (all income levels) and ATMs(per 100,000 adults) of Angola?
Keep it short and to the point. 8.03. In the year 2005, what is the difference between the ATMs(per 100,000 adults) of Middle East & North Africa (all income levels) and ATMs(per 100,000 adults) of Congo (Republic)?
Provide a succinct answer. 9.23. In the year 2005, what is the difference between the ATMs(per 100,000 adults) in Middle East & North Africa (all income levels) and ATMs(per 100,000 adults) in Thailand?
Make the answer very short. -19.86. In the year 2005, what is the difference between the ATMs(per 100,000 adults) in Angola and ATMs(per 100,000 adults) in Congo (Republic)?
Offer a very short reply. 1.2. In the year 2005, what is the difference between the ATMs(per 100,000 adults) of Angola and ATMs(per 100,000 adults) of Thailand?
Your answer should be very brief. -27.89. In the year 2005, what is the difference between the ATMs(per 100,000 adults) of Congo (Republic) and ATMs(per 100,000 adults) of Thailand?
Provide a succinct answer. -29.09. In the year 2006, what is the difference between the ATMs(per 100,000 adults) of Middle East & North Africa (all income levels) and ATMs(per 100,000 adults) of Angola?
Your answer should be compact. 6.03. In the year 2006, what is the difference between the ATMs(per 100,000 adults) in Middle East & North Africa (all income levels) and ATMs(per 100,000 adults) in Congo (Republic)?
Your response must be concise. 9.05. In the year 2006, what is the difference between the ATMs(per 100,000 adults) of Middle East & North Africa (all income levels) and ATMs(per 100,000 adults) of Thailand?
Offer a very short reply. -31.28. In the year 2006, what is the difference between the ATMs(per 100,000 adults) of Angola and ATMs(per 100,000 adults) of Congo (Republic)?
Your answer should be compact. 3.02. In the year 2006, what is the difference between the ATMs(per 100,000 adults) of Angola and ATMs(per 100,000 adults) of Thailand?
Offer a terse response. -37.31. In the year 2006, what is the difference between the ATMs(per 100,000 adults) of Congo (Republic) and ATMs(per 100,000 adults) of Thailand?
Make the answer very short. -40.33. In the year 2007, what is the difference between the ATMs(per 100,000 adults) in Middle East & North Africa (all income levels) and ATMs(per 100,000 adults) in Angola?
Ensure brevity in your answer.  9. In the year 2007, what is the difference between the ATMs(per 100,000 adults) in Middle East & North Africa (all income levels) and ATMs(per 100,000 adults) in Congo (Republic)?
Ensure brevity in your answer.  13.59. In the year 2007, what is the difference between the ATMs(per 100,000 adults) of Middle East & North Africa (all income levels) and ATMs(per 100,000 adults) of Thailand?
Provide a short and direct response. -33.53. In the year 2007, what is the difference between the ATMs(per 100,000 adults) in Angola and ATMs(per 100,000 adults) in Congo (Republic)?
Offer a very short reply. 4.59. In the year 2007, what is the difference between the ATMs(per 100,000 adults) of Angola and ATMs(per 100,000 adults) of Thailand?
Provide a succinct answer. -42.53. In the year 2007, what is the difference between the ATMs(per 100,000 adults) of Congo (Republic) and ATMs(per 100,000 adults) of Thailand?
Provide a short and direct response. -47.12. In the year 2008, what is the difference between the ATMs(per 100,000 adults) in Middle East & North Africa (all income levels) and ATMs(per 100,000 adults) in Angola?
Offer a terse response. 8.99. In the year 2008, what is the difference between the ATMs(per 100,000 adults) of Middle East & North Africa (all income levels) and ATMs(per 100,000 adults) of Congo (Republic)?
Your response must be concise. 15.34. In the year 2008, what is the difference between the ATMs(per 100,000 adults) of Middle East & North Africa (all income levels) and ATMs(per 100,000 adults) of Thailand?
Your answer should be compact. -49.65. In the year 2008, what is the difference between the ATMs(per 100,000 adults) in Angola and ATMs(per 100,000 adults) in Congo (Republic)?
Make the answer very short. 6.35. In the year 2008, what is the difference between the ATMs(per 100,000 adults) of Angola and ATMs(per 100,000 adults) of Thailand?
Offer a terse response. -58.64. In the year 2008, what is the difference between the ATMs(per 100,000 adults) of Congo (Republic) and ATMs(per 100,000 adults) of Thailand?
Your response must be concise. -64.99. In the year 2009, what is the difference between the ATMs(per 100,000 adults) of Middle East & North Africa (all income levels) and ATMs(per 100,000 adults) of Angola?
Keep it short and to the point. 8.44. In the year 2009, what is the difference between the ATMs(per 100,000 adults) of Middle East & North Africa (all income levels) and ATMs(per 100,000 adults) of Congo (Republic)?
Provide a succinct answer. 17.09. In the year 2009, what is the difference between the ATMs(per 100,000 adults) in Middle East & North Africa (all income levels) and ATMs(per 100,000 adults) in Thailand?
Provide a succinct answer. -55.79. In the year 2009, what is the difference between the ATMs(per 100,000 adults) in Angola and ATMs(per 100,000 adults) in Congo (Republic)?
Ensure brevity in your answer.  8.65. In the year 2009, what is the difference between the ATMs(per 100,000 adults) in Angola and ATMs(per 100,000 adults) in Thailand?
Your answer should be compact. -64.24. In the year 2009, what is the difference between the ATMs(per 100,000 adults) in Congo (Republic) and ATMs(per 100,000 adults) in Thailand?
Your answer should be very brief. -72.89. In the year 2010, what is the difference between the ATMs(per 100,000 adults) of Middle East & North Africa (all income levels) and ATMs(per 100,000 adults) of Angola?
Provide a short and direct response. 8.05. In the year 2010, what is the difference between the ATMs(per 100,000 adults) in Middle East & North Africa (all income levels) and ATMs(per 100,000 adults) in Congo (Republic)?
Provide a short and direct response. 18.66. In the year 2010, what is the difference between the ATMs(per 100,000 adults) in Middle East & North Africa (all income levels) and ATMs(per 100,000 adults) in Thailand?
Keep it short and to the point. -62.34. In the year 2010, what is the difference between the ATMs(per 100,000 adults) in Angola and ATMs(per 100,000 adults) in Congo (Republic)?
Your answer should be very brief. 10.61. In the year 2010, what is the difference between the ATMs(per 100,000 adults) of Angola and ATMs(per 100,000 adults) of Thailand?
Your answer should be compact. -70.39. In the year 2010, what is the difference between the ATMs(per 100,000 adults) in Congo (Republic) and ATMs(per 100,000 adults) in Thailand?
Offer a terse response. -81. In the year 2011, what is the difference between the ATMs(per 100,000 adults) in Middle East & North Africa (all income levels) and ATMs(per 100,000 adults) in Angola?
Offer a terse response. 6.3. In the year 2011, what is the difference between the ATMs(per 100,000 adults) in Middle East & North Africa (all income levels) and ATMs(per 100,000 adults) in Congo (Republic)?
Offer a very short reply. 19.24. In the year 2011, what is the difference between the ATMs(per 100,000 adults) in Middle East & North Africa (all income levels) and ATMs(per 100,000 adults) in Thailand?
Give a very brief answer. -66.67. In the year 2011, what is the difference between the ATMs(per 100,000 adults) of Angola and ATMs(per 100,000 adults) of Congo (Republic)?
Offer a terse response. 12.94. In the year 2011, what is the difference between the ATMs(per 100,000 adults) in Angola and ATMs(per 100,000 adults) in Thailand?
Give a very brief answer. -72.97. In the year 2011, what is the difference between the ATMs(per 100,000 adults) in Congo (Republic) and ATMs(per 100,000 adults) in Thailand?
Your response must be concise. -85.91. What is the ratio of the ATMs(per 100,000 adults) of Middle East & North Africa (all income levels) in 2004 to that in 2005?
Offer a very short reply. 0.87. What is the ratio of the ATMs(per 100,000 adults) of Angola in 2004 to that in 2005?
Your answer should be very brief. 0.59. What is the ratio of the ATMs(per 100,000 adults) of Congo (Republic) in 2004 to that in 2005?
Give a very brief answer. 0.93. What is the ratio of the ATMs(per 100,000 adults) of Thailand in 2004 to that in 2005?
Your response must be concise. 0.68. What is the ratio of the ATMs(per 100,000 adults) in Middle East & North Africa (all income levels) in 2004 to that in 2006?
Give a very brief answer. 0.87. What is the ratio of the ATMs(per 100,000 adults) in Angola in 2004 to that in 2006?
Give a very brief answer. 0.28. What is the ratio of the ATMs(per 100,000 adults) of Congo (Republic) in 2004 to that in 2006?
Offer a very short reply. 0.81. What is the ratio of the ATMs(per 100,000 adults) in Thailand in 2004 to that in 2006?
Offer a very short reply. 0.49. What is the ratio of the ATMs(per 100,000 adults) in Middle East & North Africa (all income levels) in 2004 to that in 2007?
Your response must be concise. 0.59. What is the ratio of the ATMs(per 100,000 adults) in Angola in 2004 to that in 2007?
Your answer should be compact. 0.19. What is the ratio of the ATMs(per 100,000 adults) of Congo (Republic) in 2004 to that in 2007?
Your answer should be compact. 0.73. What is the ratio of the ATMs(per 100,000 adults) of Thailand in 2004 to that in 2007?
Ensure brevity in your answer.  0.42. What is the ratio of the ATMs(per 100,000 adults) in Middle East & North Africa (all income levels) in 2004 to that in 2008?
Provide a short and direct response. 0.51. What is the ratio of the ATMs(per 100,000 adults) of Angola in 2004 to that in 2008?
Offer a terse response. 0.14. What is the ratio of the ATMs(per 100,000 adults) in Congo (Republic) in 2004 to that in 2008?
Your answer should be very brief. 0.43. What is the ratio of the ATMs(per 100,000 adults) of Thailand in 2004 to that in 2008?
Provide a short and direct response. 0.3. What is the ratio of the ATMs(per 100,000 adults) in Middle East & North Africa (all income levels) in 2004 to that in 2009?
Provide a short and direct response. 0.46. What is the ratio of the ATMs(per 100,000 adults) in Angola in 2004 to that in 2009?
Provide a succinct answer. 0.1. What is the ratio of the ATMs(per 100,000 adults) in Congo (Republic) in 2004 to that in 2009?
Offer a very short reply. 0.35. What is the ratio of the ATMs(per 100,000 adults) in Thailand in 2004 to that in 2009?
Give a very brief answer. 0.27. What is the ratio of the ATMs(per 100,000 adults) of Middle East & North Africa (all income levels) in 2004 to that in 2010?
Offer a very short reply. 0.41. What is the ratio of the ATMs(per 100,000 adults) in Angola in 2004 to that in 2010?
Give a very brief answer. 0.08. What is the ratio of the ATMs(per 100,000 adults) in Congo (Republic) in 2004 to that in 2010?
Offer a very short reply. 0.25. What is the ratio of the ATMs(per 100,000 adults) in Thailand in 2004 to that in 2010?
Provide a succinct answer. 0.24. What is the ratio of the ATMs(per 100,000 adults) in Middle East & North Africa (all income levels) in 2004 to that in 2011?
Make the answer very short. 0.39. What is the ratio of the ATMs(per 100,000 adults) in Angola in 2004 to that in 2011?
Provide a succinct answer. 0.07. What is the ratio of the ATMs(per 100,000 adults) of Congo (Republic) in 2004 to that in 2011?
Provide a short and direct response. 0.2. What is the ratio of the ATMs(per 100,000 adults) of Thailand in 2004 to that in 2011?
Provide a succinct answer. 0.23. What is the ratio of the ATMs(per 100,000 adults) of Middle East & North Africa (all income levels) in 2005 to that in 2006?
Provide a short and direct response. 1.01. What is the ratio of the ATMs(per 100,000 adults) of Angola in 2005 to that in 2006?
Offer a terse response. 0.48. What is the ratio of the ATMs(per 100,000 adults) of Congo (Republic) in 2005 to that in 2006?
Your answer should be very brief. 0.87. What is the ratio of the ATMs(per 100,000 adults) in Thailand in 2005 to that in 2006?
Your response must be concise. 0.72. What is the ratio of the ATMs(per 100,000 adults) of Middle East & North Africa (all income levels) in 2005 to that in 2007?
Your answer should be compact. 0.68. What is the ratio of the ATMs(per 100,000 adults) of Angola in 2005 to that in 2007?
Provide a short and direct response. 0.33. What is the ratio of the ATMs(per 100,000 adults) of Congo (Republic) in 2005 to that in 2007?
Provide a short and direct response. 0.78. What is the ratio of the ATMs(per 100,000 adults) in Thailand in 2005 to that in 2007?
Give a very brief answer. 0.62. What is the ratio of the ATMs(per 100,000 adults) in Middle East & North Africa (all income levels) in 2005 to that in 2008?
Your answer should be compact. 0.59. What is the ratio of the ATMs(per 100,000 adults) in Angola in 2005 to that in 2008?
Your answer should be compact. 0.23. What is the ratio of the ATMs(per 100,000 adults) of Congo (Republic) in 2005 to that in 2008?
Keep it short and to the point. 0.46. What is the ratio of the ATMs(per 100,000 adults) in Thailand in 2005 to that in 2008?
Your response must be concise. 0.45. What is the ratio of the ATMs(per 100,000 adults) of Middle East & North Africa (all income levels) in 2005 to that in 2009?
Your response must be concise. 0.53. What is the ratio of the ATMs(per 100,000 adults) of Angola in 2005 to that in 2009?
Offer a very short reply. 0.17. What is the ratio of the ATMs(per 100,000 adults) in Congo (Republic) in 2005 to that in 2009?
Offer a very short reply. 0.38. What is the ratio of the ATMs(per 100,000 adults) of Thailand in 2005 to that in 2009?
Your answer should be compact. 0.4. What is the ratio of the ATMs(per 100,000 adults) in Middle East & North Africa (all income levels) in 2005 to that in 2010?
Your response must be concise. 0.47. What is the ratio of the ATMs(per 100,000 adults) in Angola in 2005 to that in 2010?
Provide a succinct answer. 0.14. What is the ratio of the ATMs(per 100,000 adults) of Congo (Republic) in 2005 to that in 2010?
Your answer should be very brief. 0.27. What is the ratio of the ATMs(per 100,000 adults) of Thailand in 2005 to that in 2010?
Keep it short and to the point. 0.36. What is the ratio of the ATMs(per 100,000 adults) in Middle East & North Africa (all income levels) in 2005 to that in 2011?
Offer a terse response. 0.45. What is the ratio of the ATMs(per 100,000 adults) of Angola in 2005 to that in 2011?
Give a very brief answer. 0.11. What is the ratio of the ATMs(per 100,000 adults) in Congo (Republic) in 2005 to that in 2011?
Give a very brief answer. 0.21. What is the ratio of the ATMs(per 100,000 adults) in Thailand in 2005 to that in 2011?
Give a very brief answer. 0.34. What is the ratio of the ATMs(per 100,000 adults) of Middle East & North Africa (all income levels) in 2006 to that in 2007?
Provide a succinct answer. 0.68. What is the ratio of the ATMs(per 100,000 adults) of Angola in 2006 to that in 2007?
Give a very brief answer. 0.69. What is the ratio of the ATMs(per 100,000 adults) of Congo (Republic) in 2006 to that in 2007?
Your answer should be compact. 0.89. What is the ratio of the ATMs(per 100,000 adults) in Thailand in 2006 to that in 2007?
Offer a terse response. 0.86. What is the ratio of the ATMs(per 100,000 adults) of Middle East & North Africa (all income levels) in 2006 to that in 2008?
Give a very brief answer. 0.59. What is the ratio of the ATMs(per 100,000 adults) in Angola in 2006 to that in 2008?
Offer a terse response. 0.48. What is the ratio of the ATMs(per 100,000 adults) of Congo (Republic) in 2006 to that in 2008?
Give a very brief answer. 0.53. What is the ratio of the ATMs(per 100,000 adults) in Thailand in 2006 to that in 2008?
Your answer should be very brief. 0.62. What is the ratio of the ATMs(per 100,000 adults) of Middle East & North Africa (all income levels) in 2006 to that in 2009?
Make the answer very short. 0.52. What is the ratio of the ATMs(per 100,000 adults) in Angola in 2006 to that in 2009?
Your answer should be very brief. 0.36. What is the ratio of the ATMs(per 100,000 adults) of Congo (Republic) in 2006 to that in 2009?
Offer a terse response. 0.43. What is the ratio of the ATMs(per 100,000 adults) in Thailand in 2006 to that in 2009?
Keep it short and to the point. 0.55. What is the ratio of the ATMs(per 100,000 adults) of Middle East & North Africa (all income levels) in 2006 to that in 2010?
Ensure brevity in your answer.  0.47. What is the ratio of the ATMs(per 100,000 adults) in Angola in 2006 to that in 2010?
Provide a succinct answer. 0.29. What is the ratio of the ATMs(per 100,000 adults) in Congo (Republic) in 2006 to that in 2010?
Your answer should be compact. 0.31. What is the ratio of the ATMs(per 100,000 adults) of Thailand in 2006 to that in 2010?
Make the answer very short. 0.49. What is the ratio of the ATMs(per 100,000 adults) of Middle East & North Africa (all income levels) in 2006 to that in 2011?
Your answer should be very brief. 0.44. What is the ratio of the ATMs(per 100,000 adults) of Angola in 2006 to that in 2011?
Offer a terse response. 0.24. What is the ratio of the ATMs(per 100,000 adults) of Congo (Republic) in 2006 to that in 2011?
Offer a terse response. 0.25. What is the ratio of the ATMs(per 100,000 adults) in Thailand in 2006 to that in 2011?
Your response must be concise. 0.46. What is the ratio of the ATMs(per 100,000 adults) of Middle East & North Africa (all income levels) in 2007 to that in 2008?
Offer a terse response. 0.87. What is the ratio of the ATMs(per 100,000 adults) in Angola in 2007 to that in 2008?
Provide a short and direct response. 0.7. What is the ratio of the ATMs(per 100,000 adults) in Congo (Republic) in 2007 to that in 2008?
Offer a very short reply. 0.6. What is the ratio of the ATMs(per 100,000 adults) of Thailand in 2007 to that in 2008?
Make the answer very short. 0.72. What is the ratio of the ATMs(per 100,000 adults) of Middle East & North Africa (all income levels) in 2007 to that in 2009?
Provide a succinct answer. 0.77. What is the ratio of the ATMs(per 100,000 adults) of Angola in 2007 to that in 2009?
Your response must be concise. 0.52. What is the ratio of the ATMs(per 100,000 adults) in Congo (Republic) in 2007 to that in 2009?
Your answer should be very brief. 0.48. What is the ratio of the ATMs(per 100,000 adults) in Thailand in 2007 to that in 2009?
Ensure brevity in your answer.  0.64. What is the ratio of the ATMs(per 100,000 adults) in Middle East & North Africa (all income levels) in 2007 to that in 2010?
Give a very brief answer. 0.69. What is the ratio of the ATMs(per 100,000 adults) of Angola in 2007 to that in 2010?
Make the answer very short. 0.42. What is the ratio of the ATMs(per 100,000 adults) of Congo (Republic) in 2007 to that in 2010?
Your response must be concise. 0.34. What is the ratio of the ATMs(per 100,000 adults) of Thailand in 2007 to that in 2010?
Your answer should be compact. 0.58. What is the ratio of the ATMs(per 100,000 adults) of Middle East & North Africa (all income levels) in 2007 to that in 2011?
Offer a terse response. 0.66. What is the ratio of the ATMs(per 100,000 adults) in Angola in 2007 to that in 2011?
Offer a terse response. 0.34. What is the ratio of the ATMs(per 100,000 adults) in Congo (Republic) in 2007 to that in 2011?
Keep it short and to the point. 0.28. What is the ratio of the ATMs(per 100,000 adults) in Thailand in 2007 to that in 2011?
Make the answer very short. 0.54. What is the ratio of the ATMs(per 100,000 adults) of Middle East & North Africa (all income levels) in 2008 to that in 2009?
Make the answer very short. 0.89. What is the ratio of the ATMs(per 100,000 adults) in Angola in 2008 to that in 2009?
Give a very brief answer. 0.74. What is the ratio of the ATMs(per 100,000 adults) of Congo (Republic) in 2008 to that in 2009?
Offer a very short reply. 0.81. What is the ratio of the ATMs(per 100,000 adults) in Thailand in 2008 to that in 2009?
Give a very brief answer. 0.89. What is the ratio of the ATMs(per 100,000 adults) of Middle East & North Africa (all income levels) in 2008 to that in 2010?
Provide a short and direct response. 0.8. What is the ratio of the ATMs(per 100,000 adults) of Angola in 2008 to that in 2010?
Give a very brief answer. 0.59. What is the ratio of the ATMs(per 100,000 adults) in Congo (Republic) in 2008 to that in 2010?
Offer a very short reply. 0.57. What is the ratio of the ATMs(per 100,000 adults) of Thailand in 2008 to that in 2010?
Your response must be concise. 0.8. What is the ratio of the ATMs(per 100,000 adults) of Middle East & North Africa (all income levels) in 2008 to that in 2011?
Keep it short and to the point. 0.76. What is the ratio of the ATMs(per 100,000 adults) of Angola in 2008 to that in 2011?
Provide a short and direct response. 0.49. What is the ratio of the ATMs(per 100,000 adults) in Congo (Republic) in 2008 to that in 2011?
Your answer should be very brief. 0.46. What is the ratio of the ATMs(per 100,000 adults) of Thailand in 2008 to that in 2011?
Provide a succinct answer. 0.75. What is the ratio of the ATMs(per 100,000 adults) in Middle East & North Africa (all income levels) in 2009 to that in 2010?
Offer a very short reply. 0.9. What is the ratio of the ATMs(per 100,000 adults) of Angola in 2009 to that in 2010?
Offer a very short reply. 0.8. What is the ratio of the ATMs(per 100,000 adults) in Congo (Republic) in 2009 to that in 2010?
Ensure brevity in your answer.  0.71. What is the ratio of the ATMs(per 100,000 adults) in Thailand in 2009 to that in 2010?
Provide a short and direct response. 0.9. What is the ratio of the ATMs(per 100,000 adults) of Middle East & North Africa (all income levels) in 2009 to that in 2011?
Provide a succinct answer. 0.85. What is the ratio of the ATMs(per 100,000 adults) in Angola in 2009 to that in 2011?
Keep it short and to the point. 0.65. What is the ratio of the ATMs(per 100,000 adults) in Congo (Republic) in 2009 to that in 2011?
Offer a very short reply. 0.57. What is the ratio of the ATMs(per 100,000 adults) of Thailand in 2009 to that in 2011?
Provide a succinct answer. 0.84. What is the ratio of the ATMs(per 100,000 adults) in Middle East & North Africa (all income levels) in 2010 to that in 2011?
Offer a terse response. 0.95. What is the ratio of the ATMs(per 100,000 adults) in Angola in 2010 to that in 2011?
Make the answer very short. 0.82. What is the ratio of the ATMs(per 100,000 adults) of Congo (Republic) in 2010 to that in 2011?
Provide a succinct answer. 0.81. What is the ratio of the ATMs(per 100,000 adults) of Thailand in 2010 to that in 2011?
Offer a very short reply. 0.94. What is the difference between the highest and the second highest ATMs(per 100,000 adults) of Middle East & North Africa (all income levels)?
Your response must be concise. 1.06. What is the difference between the highest and the second highest ATMs(per 100,000 adults) of Angola?
Your answer should be very brief. 2.81. What is the difference between the highest and the second highest ATMs(per 100,000 adults) in Congo (Republic)?
Make the answer very short. 0.48. What is the difference between the highest and the second highest ATMs(per 100,000 adults) in Thailand?
Ensure brevity in your answer.  5.39. What is the difference between the highest and the lowest ATMs(per 100,000 adults) in Middle East & North Africa (all income levels)?
Offer a very short reply. 13.29. What is the difference between the highest and the lowest ATMs(per 100,000 adults) in Angola?
Give a very brief answer. 14.42. What is the difference between the highest and the lowest ATMs(per 100,000 adults) of Congo (Republic)?
Offer a terse response. 2. What is the difference between the highest and the lowest ATMs(per 100,000 adults) in Thailand?
Offer a very short reply. 68.32. 